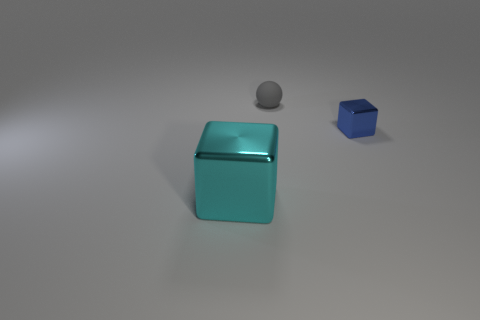Is there any other thing that has the same material as the small gray thing?
Give a very brief answer. No. Is the small metal thing the same color as the tiny rubber object?
Make the answer very short. No. Are there any other things that are the same size as the blue object?
Offer a very short reply. Yes. There is a thing that is behind the metal block that is on the right side of the large cyan block; what is its material?
Ensure brevity in your answer.  Rubber. There is a thing that is in front of the sphere and left of the blue block; what is its shape?
Your answer should be compact. Cube. What is the size of the cyan thing that is the same shape as the blue thing?
Ensure brevity in your answer.  Large. Are there fewer shiny things left of the small block than yellow cylinders?
Your response must be concise. No. There is a metallic cube on the right side of the tiny matte object; what is its size?
Provide a succinct answer. Small. There is a big object that is the same shape as the small blue shiny object; what color is it?
Offer a terse response. Cyan. What number of small cubes are the same color as the rubber thing?
Ensure brevity in your answer.  0. 